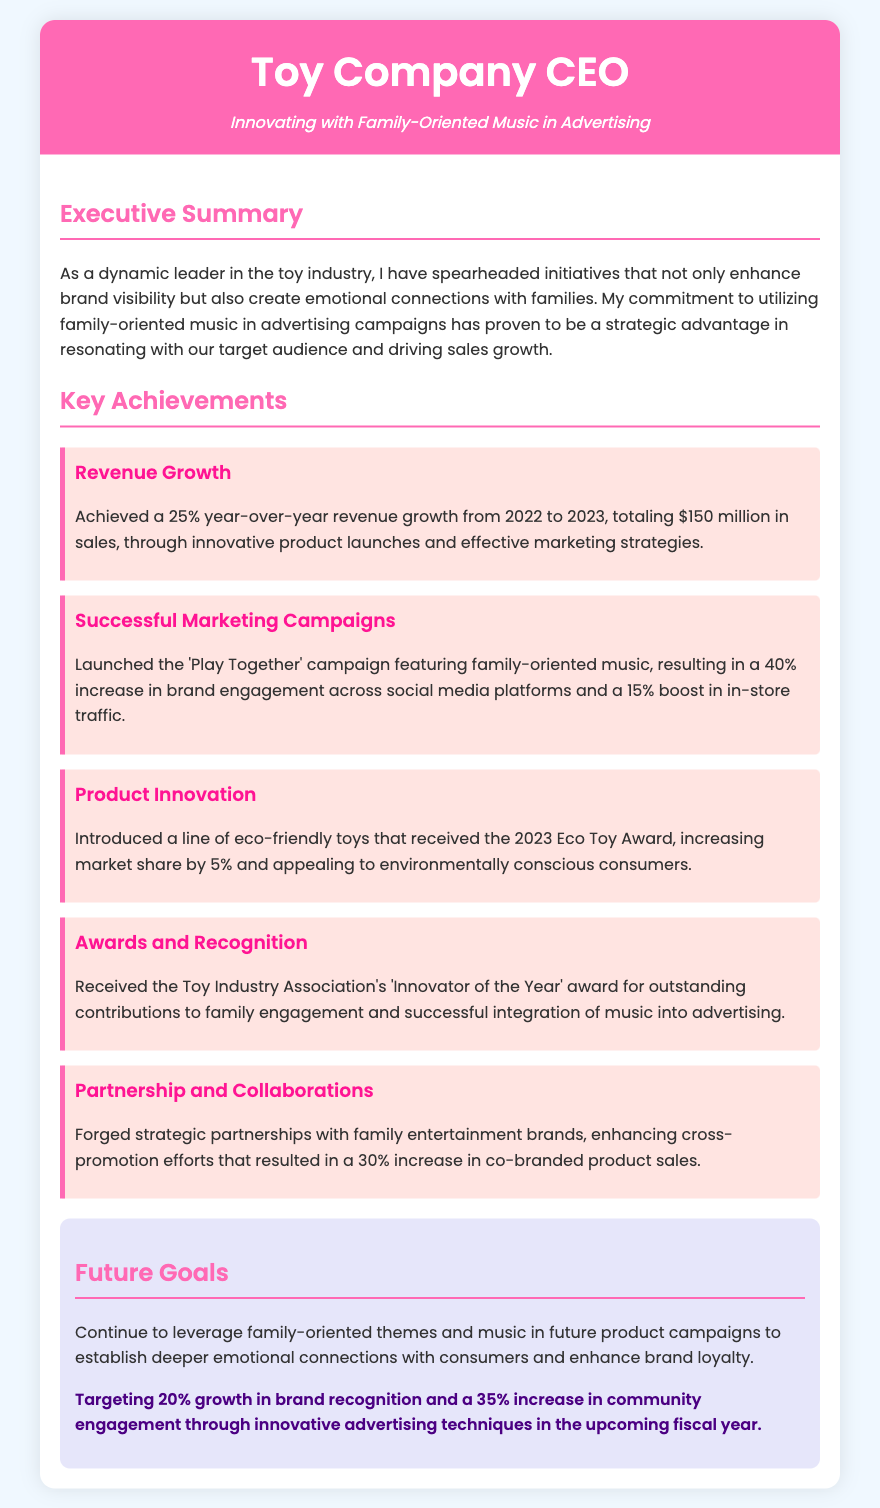What percentage year-over-year revenue growth was achieved? The document states a 25% growth in revenue from 2022 to 2023.
Answer: 25% What was the total sales amount reported for the year? The total sales reported in the document is $150 million for the year 2023.
Answer: $150 million What marketing campaign resulted in a 40% increase in brand engagement? The 'Play Together' campaign featuring family-oriented music led to this increase.
Answer: 'Play Together' What award was received for contributions to family engagement? The document mentions the 'Innovator of the Year' award from the Toy Industry Association.
Answer: Innovator of the Year What type of toys was introduced that received the 2023 Eco Toy Award? The document indicates a line of eco-friendly toys was introduced.
Answer: Eco-friendly toys What is the target growth in brand recognition for the upcoming fiscal year? The document states a target of 20% growth in brand recognition.
Answer: 20% What increase in co-branded product sales resulted from strategic partnerships? The document states there was a 30% increase in co-branded product sales due to partnerships.
Answer: 30% What future goal involves leveraging family-oriented themes in advertising? The document highlights the goal of establishing deeper emotional connections with consumers.
Answer: Deeper emotional connections 